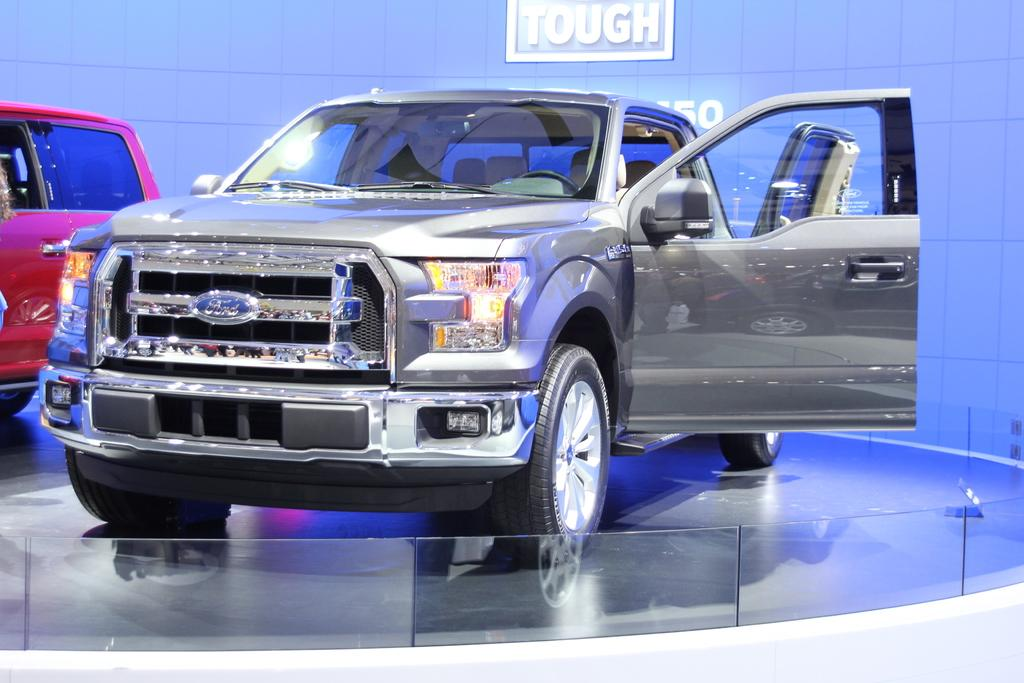What can be seen in the middle of the image? There are two vehicles in the middle of the image. What is visible in the background of the image? There is a wall in the background of the image. Can you describe the text logo at the top of the image? Unfortunately, there is no information about a text logo in the provided facts. How many clover leaves can be seen on the vehicles in the image? There is no mention of clover leaves in the provided facts, and they are not visible in the image. 